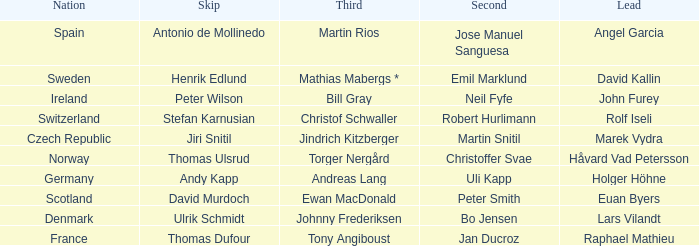When did France come in second? Jan Ducroz. 